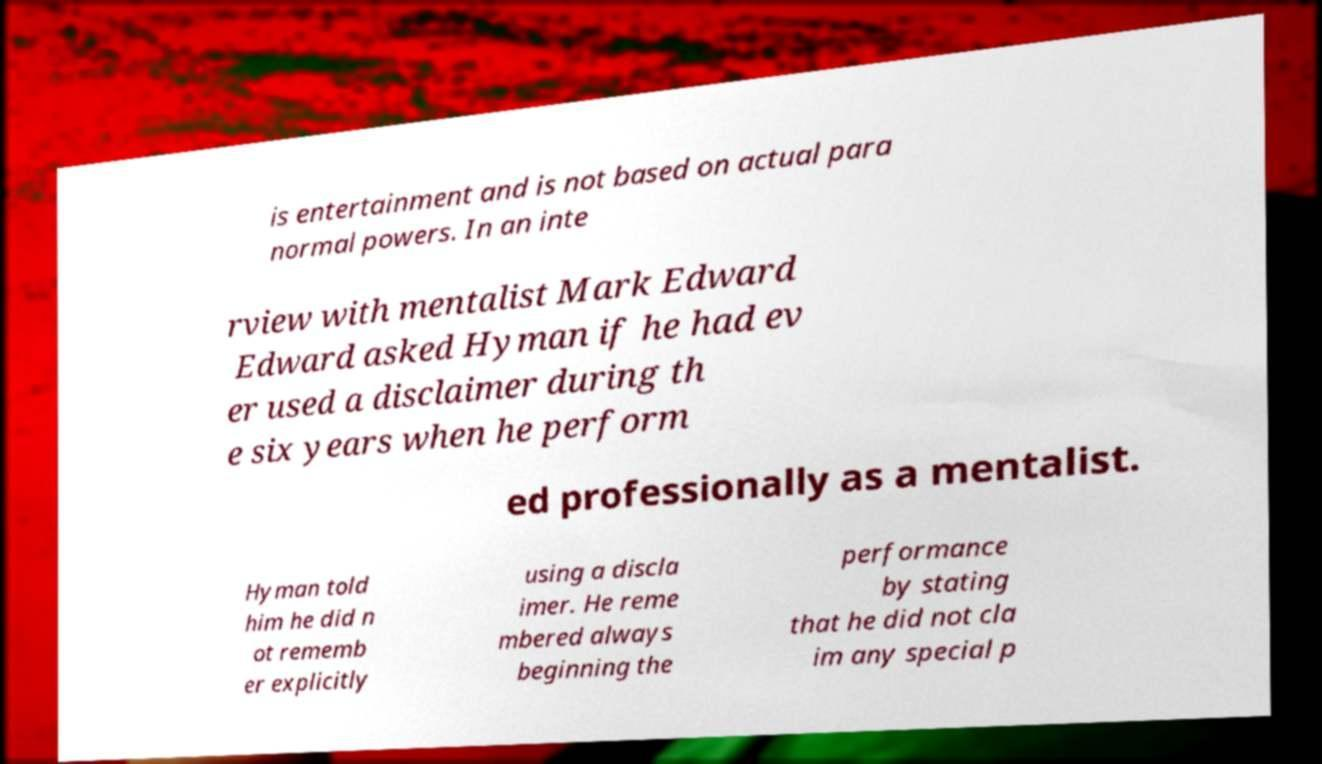There's text embedded in this image that I need extracted. Can you transcribe it verbatim? is entertainment and is not based on actual para normal powers. In an inte rview with mentalist Mark Edward Edward asked Hyman if he had ev er used a disclaimer during th e six years when he perform ed professionally as a mentalist. Hyman told him he did n ot rememb er explicitly using a discla imer. He reme mbered always beginning the performance by stating that he did not cla im any special p 